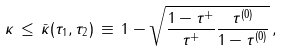<formula> <loc_0><loc_0><loc_500><loc_500>\kappa \, \leq \, \bar { \kappa } ( \tau _ { 1 } , \tau _ { 2 } ) \, \equiv \, 1 - \sqrt { \frac { 1 - \tau ^ { + } } { \tau ^ { + } } \frac { \tau ^ { ( 0 ) } } { 1 - \tau ^ { ( 0 ) } } } \, ,</formula> 